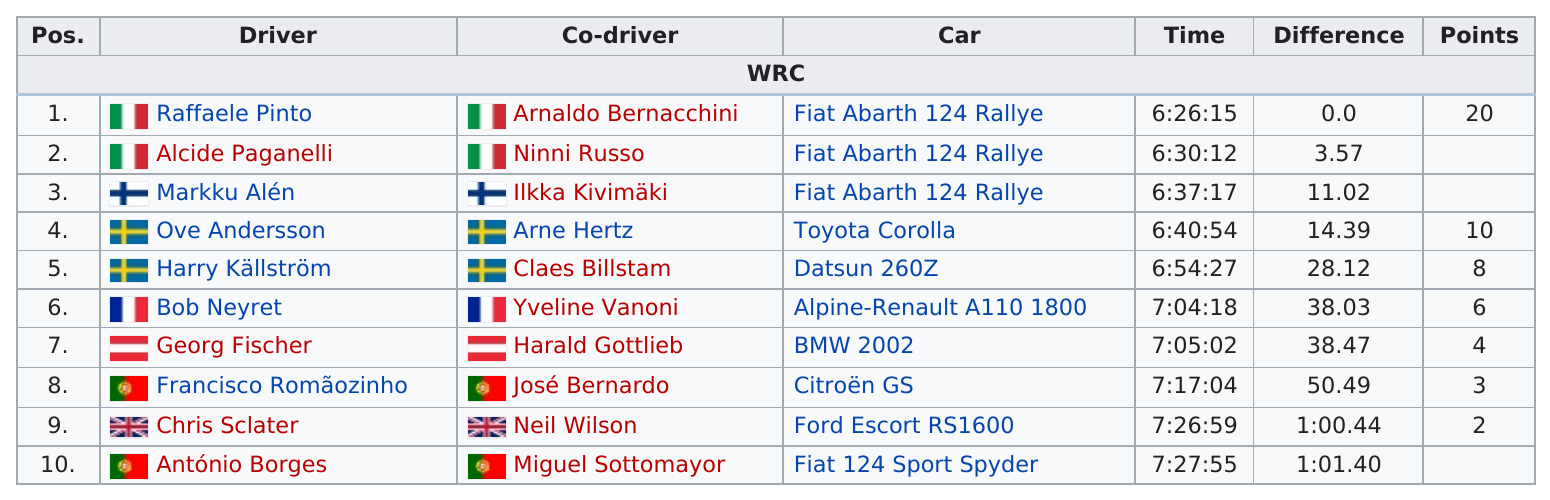Outline some significant characteristics in this image. There were drivers who earned at least 5 points during the competition. The drivers António Borges and Miguel Sottomayor came in last place. Raffaele Pinto and Arnaldo Bernacchini are the drivers and co-drivers who have accumulated the highest number of points. The driver in the sixth position completed the race in a time of 7 hours, 4 minutes, and 18 seconds. After the 7:00:00 time mark, 5 racers finished. 